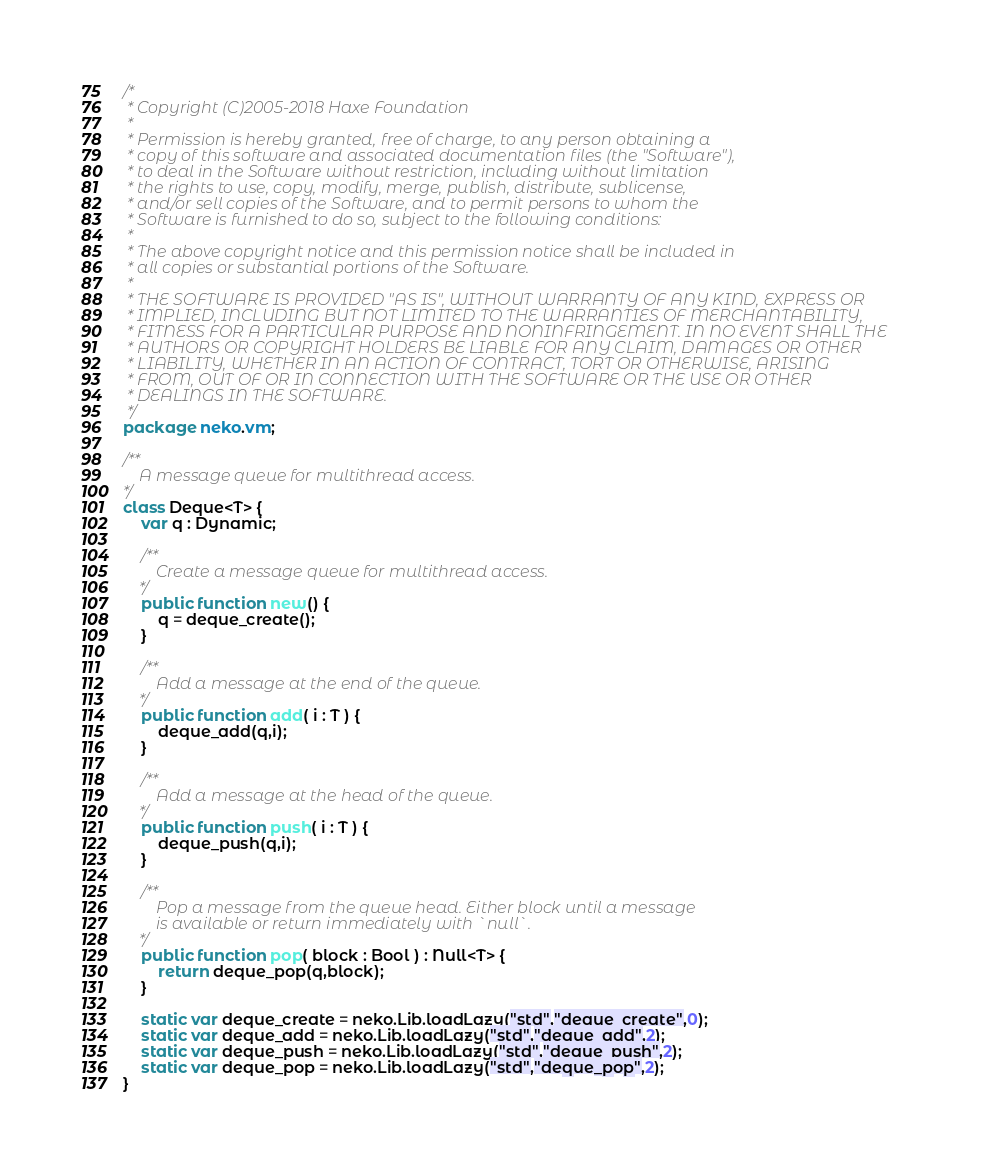Convert code to text. <code><loc_0><loc_0><loc_500><loc_500><_Haxe_>/*
 * Copyright (C)2005-2018 Haxe Foundation
 *
 * Permission is hereby granted, free of charge, to any person obtaining a
 * copy of this software and associated documentation files (the "Software"),
 * to deal in the Software without restriction, including without limitation
 * the rights to use, copy, modify, merge, publish, distribute, sublicense,
 * and/or sell copies of the Software, and to permit persons to whom the
 * Software is furnished to do so, subject to the following conditions:
 *
 * The above copyright notice and this permission notice shall be included in
 * all copies or substantial portions of the Software.
 *
 * THE SOFTWARE IS PROVIDED "AS IS", WITHOUT WARRANTY OF ANY KIND, EXPRESS OR
 * IMPLIED, INCLUDING BUT NOT LIMITED TO THE WARRANTIES OF MERCHANTABILITY,
 * FITNESS FOR A PARTICULAR PURPOSE AND NONINFRINGEMENT. IN NO EVENT SHALL THE
 * AUTHORS OR COPYRIGHT HOLDERS BE LIABLE FOR ANY CLAIM, DAMAGES OR OTHER
 * LIABILITY, WHETHER IN AN ACTION OF CONTRACT, TORT OR OTHERWISE, ARISING
 * FROM, OUT OF OR IN CONNECTION WITH THE SOFTWARE OR THE USE OR OTHER
 * DEALINGS IN THE SOFTWARE.
 */
package neko.vm;

/**
	A message queue for multithread access.
*/
class Deque<T> {
	var q : Dynamic;

	/**
		Create a message queue for multithread access.
	*/
	public function new() {
		q = deque_create();
	}

	/**
		Add a message at the end of the queue.
	*/
	public function add( i : T ) {
		deque_add(q,i);
	}

	/**
		Add a message at the head of the queue.
	*/
	public function push( i : T ) {
		deque_push(q,i);
	}

	/**
		Pop a message from the queue head. Either block until a message 
		is available or return immediately with `null`.
	*/
	public function pop( block : Bool ) : Null<T> {
		return deque_pop(q,block);
	}

	static var deque_create = neko.Lib.loadLazy("std","deque_create",0);
	static var deque_add = neko.Lib.loadLazy("std","deque_add",2);
	static var deque_push = neko.Lib.loadLazy("std","deque_push",2);
	static var deque_pop = neko.Lib.loadLazy("std","deque_pop",2);
}
</code> 